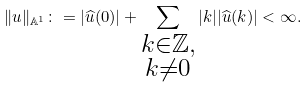Convert formula to latex. <formula><loc_0><loc_0><loc_500><loc_500>\| u \| _ { \mathbb { A } ^ { 1 } } \colon = | \widehat { u } ( 0 ) | + \sum _ { \substack { k \in \mathbb { Z } , \\ k \neq 0 } } | k | | \widehat { u } ( k ) | < \infty .</formula> 